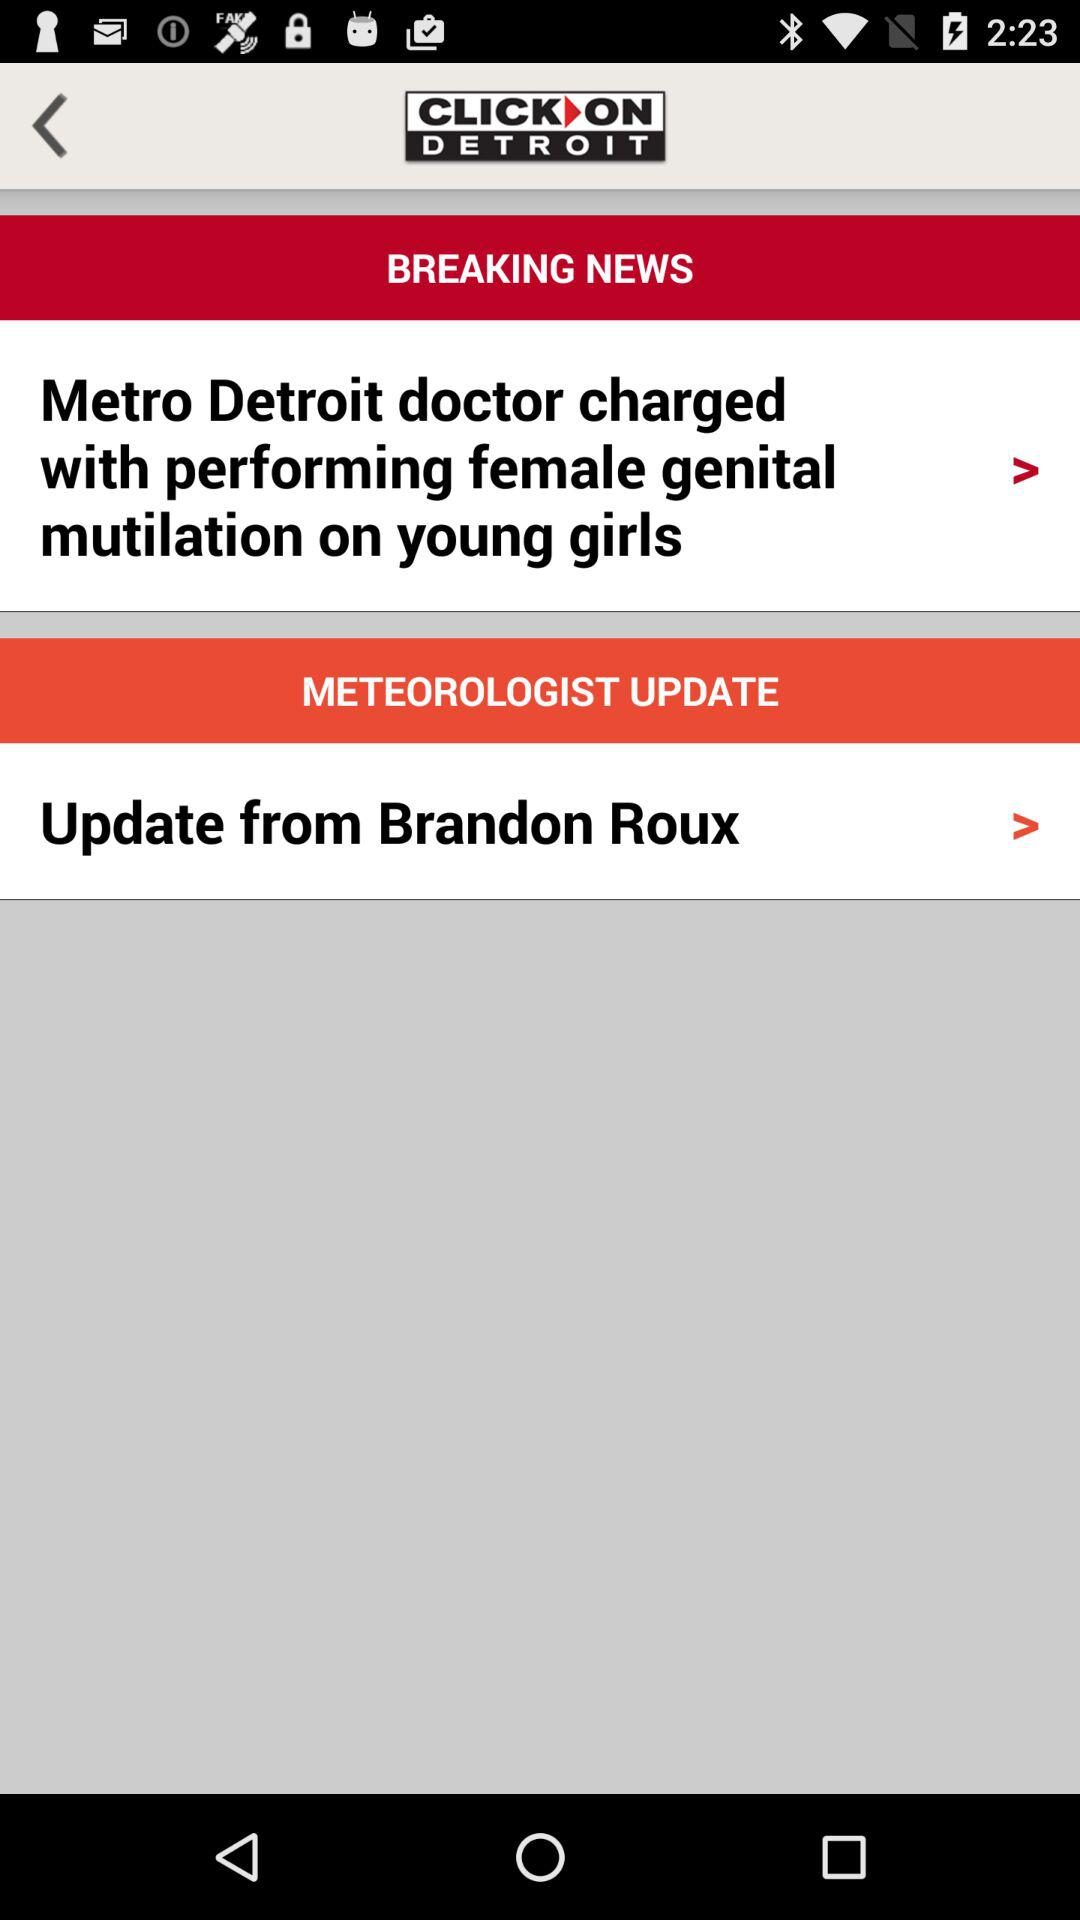Why was the Metro Detroit doctor charged? The metro detroit doctor charged with performing female genital mutilation on young girls. 